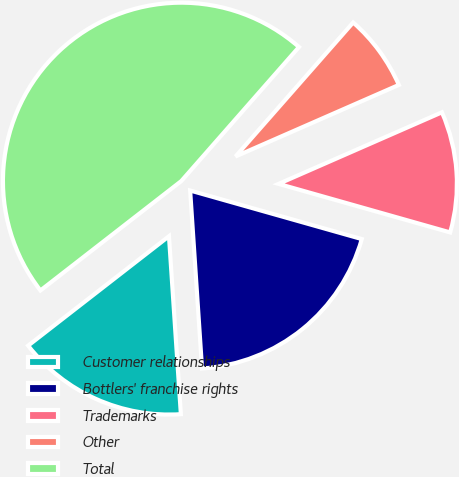Convert chart to OTSL. <chart><loc_0><loc_0><loc_500><loc_500><pie_chart><fcel>Customer relationships<fcel>Bottlers' franchise rights<fcel>Trademarks<fcel>Other<fcel>Total<nl><fcel>15.55%<fcel>19.55%<fcel>10.96%<fcel>6.96%<fcel>46.98%<nl></chart> 